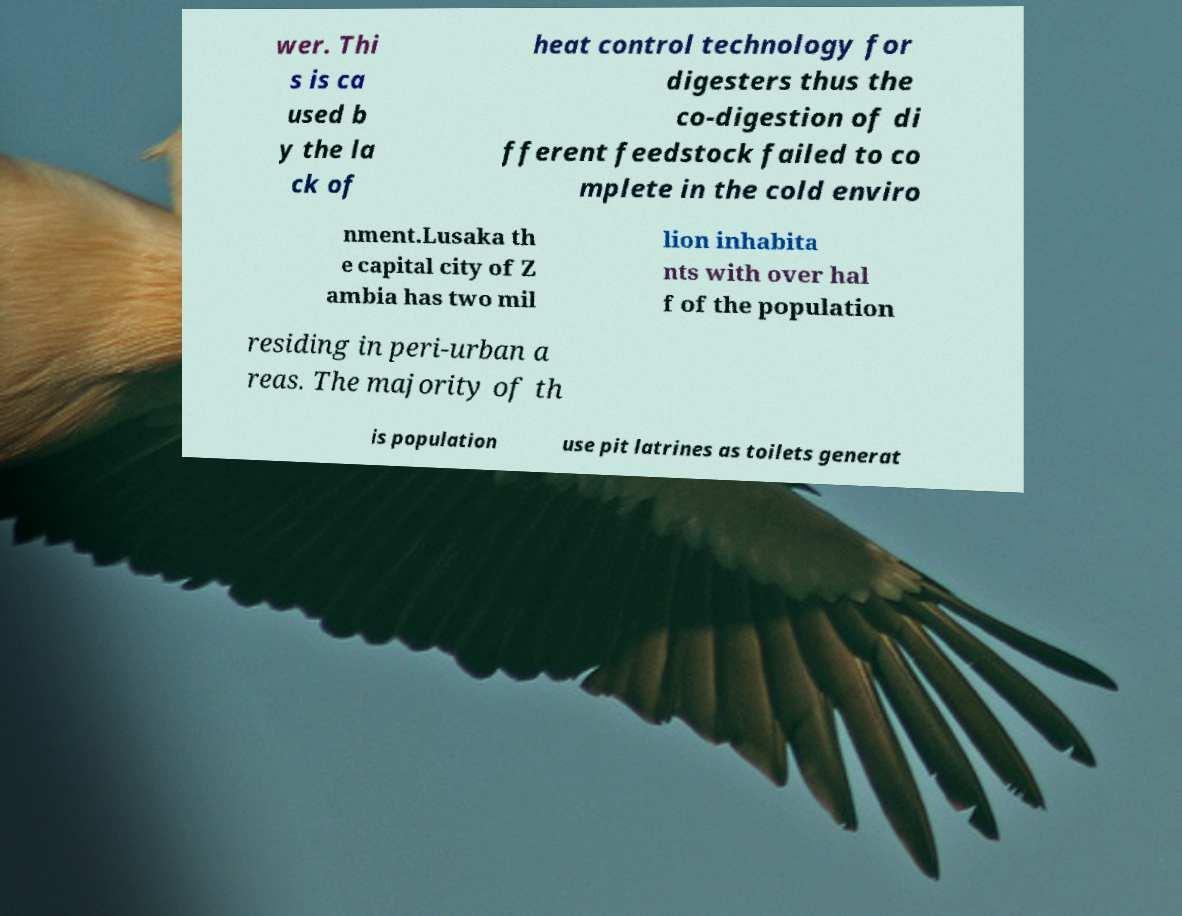What messages or text are displayed in this image? I need them in a readable, typed format. wer. Thi s is ca used b y the la ck of heat control technology for digesters thus the co-digestion of di fferent feedstock failed to co mplete in the cold enviro nment.Lusaka th e capital city of Z ambia has two mil lion inhabita nts with over hal f of the population residing in peri-urban a reas. The majority of th is population use pit latrines as toilets generat 